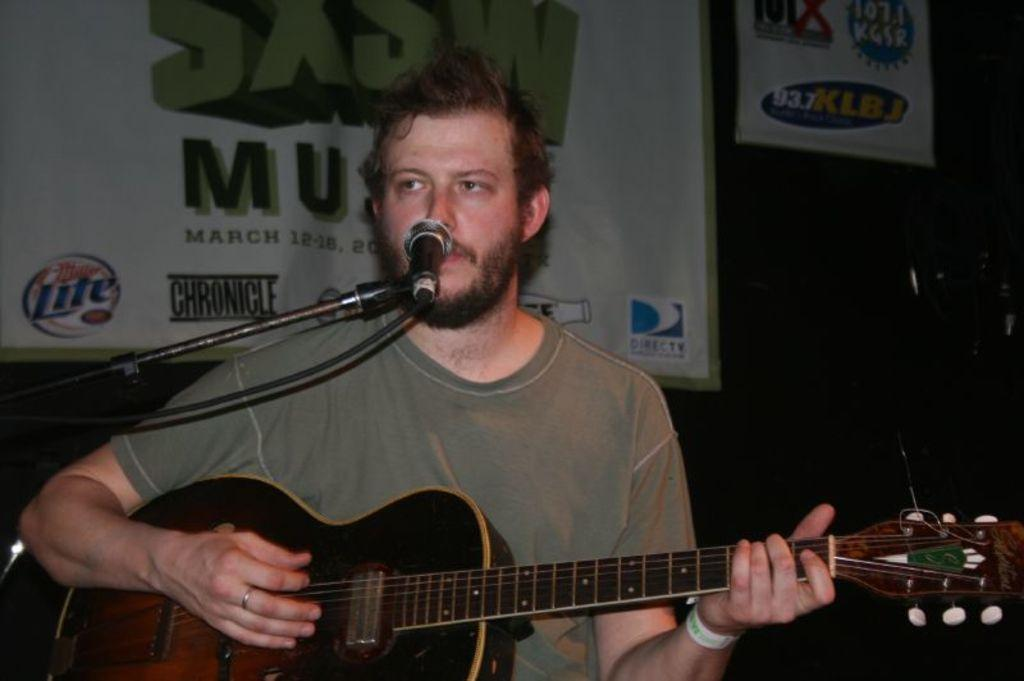What is the person in the image doing? The person is holding a guitar and is behind a microphone. What object is the person holding in the image? The person is holding a guitar. What is the person standing near in the image? The person is standing near a microphone. What can be seen in the background of the image? There is a banner in the background of the image. What type of joke can be seen written on the guitar in the image? There is no joke written on the guitar in the image; it is a musical instrument being held by the person. 